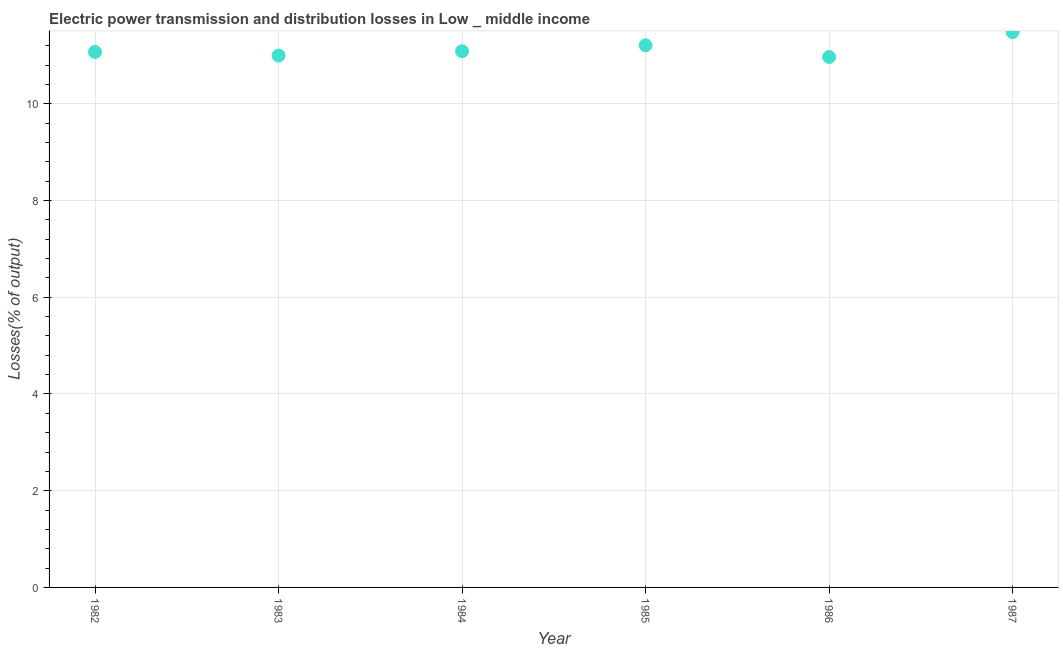What is the electric power transmission and distribution losses in 1984?
Offer a terse response. 11.09. Across all years, what is the maximum electric power transmission and distribution losses?
Make the answer very short. 11.48. Across all years, what is the minimum electric power transmission and distribution losses?
Ensure brevity in your answer.  10.97. In which year was the electric power transmission and distribution losses maximum?
Make the answer very short. 1987. In which year was the electric power transmission and distribution losses minimum?
Keep it short and to the point. 1986. What is the sum of the electric power transmission and distribution losses?
Your response must be concise. 66.82. What is the difference between the electric power transmission and distribution losses in 1982 and 1987?
Give a very brief answer. -0.41. What is the average electric power transmission and distribution losses per year?
Your response must be concise. 11.14. What is the median electric power transmission and distribution losses?
Ensure brevity in your answer.  11.08. Do a majority of the years between 1986 and 1982 (inclusive) have electric power transmission and distribution losses greater than 8.8 %?
Offer a terse response. Yes. What is the ratio of the electric power transmission and distribution losses in 1984 to that in 1985?
Your response must be concise. 0.99. Is the difference between the electric power transmission and distribution losses in 1982 and 1986 greater than the difference between any two years?
Your response must be concise. No. What is the difference between the highest and the second highest electric power transmission and distribution losses?
Make the answer very short. 0.27. What is the difference between the highest and the lowest electric power transmission and distribution losses?
Offer a very short reply. 0.51. In how many years, is the electric power transmission and distribution losses greater than the average electric power transmission and distribution losses taken over all years?
Ensure brevity in your answer.  2. What is the difference between two consecutive major ticks on the Y-axis?
Your answer should be very brief. 2. Are the values on the major ticks of Y-axis written in scientific E-notation?
Your answer should be compact. No. Does the graph contain grids?
Offer a terse response. Yes. What is the title of the graph?
Your answer should be very brief. Electric power transmission and distribution losses in Low _ middle income. What is the label or title of the Y-axis?
Ensure brevity in your answer.  Losses(% of output). What is the Losses(% of output) in 1982?
Offer a terse response. 11.07. What is the Losses(% of output) in 1983?
Keep it short and to the point. 11. What is the Losses(% of output) in 1984?
Make the answer very short. 11.09. What is the Losses(% of output) in 1985?
Keep it short and to the point. 11.21. What is the Losses(% of output) in 1986?
Give a very brief answer. 10.97. What is the Losses(% of output) in 1987?
Your answer should be very brief. 11.48. What is the difference between the Losses(% of output) in 1982 and 1983?
Give a very brief answer. 0.07. What is the difference between the Losses(% of output) in 1982 and 1984?
Offer a terse response. -0.01. What is the difference between the Losses(% of output) in 1982 and 1985?
Your response must be concise. -0.14. What is the difference between the Losses(% of output) in 1982 and 1986?
Your answer should be compact. 0.1. What is the difference between the Losses(% of output) in 1982 and 1987?
Your response must be concise. -0.41. What is the difference between the Losses(% of output) in 1983 and 1984?
Offer a terse response. -0.09. What is the difference between the Losses(% of output) in 1983 and 1985?
Give a very brief answer. -0.21. What is the difference between the Losses(% of output) in 1983 and 1986?
Offer a very short reply. 0.03. What is the difference between the Losses(% of output) in 1983 and 1987?
Make the answer very short. -0.49. What is the difference between the Losses(% of output) in 1984 and 1985?
Offer a terse response. -0.12. What is the difference between the Losses(% of output) in 1984 and 1986?
Offer a very short reply. 0.12. What is the difference between the Losses(% of output) in 1984 and 1987?
Keep it short and to the point. -0.4. What is the difference between the Losses(% of output) in 1985 and 1986?
Offer a terse response. 0.24. What is the difference between the Losses(% of output) in 1985 and 1987?
Your answer should be very brief. -0.27. What is the difference between the Losses(% of output) in 1986 and 1987?
Your answer should be very brief. -0.51. What is the ratio of the Losses(% of output) in 1982 to that in 1983?
Offer a very short reply. 1.01. What is the ratio of the Losses(% of output) in 1982 to that in 1984?
Give a very brief answer. 1. What is the ratio of the Losses(% of output) in 1982 to that in 1987?
Ensure brevity in your answer.  0.96. What is the ratio of the Losses(% of output) in 1983 to that in 1984?
Give a very brief answer. 0.99. What is the ratio of the Losses(% of output) in 1983 to that in 1985?
Your answer should be compact. 0.98. What is the ratio of the Losses(% of output) in 1983 to that in 1987?
Offer a terse response. 0.96. What is the ratio of the Losses(% of output) in 1985 to that in 1986?
Your response must be concise. 1.02. What is the ratio of the Losses(% of output) in 1986 to that in 1987?
Your response must be concise. 0.95. 